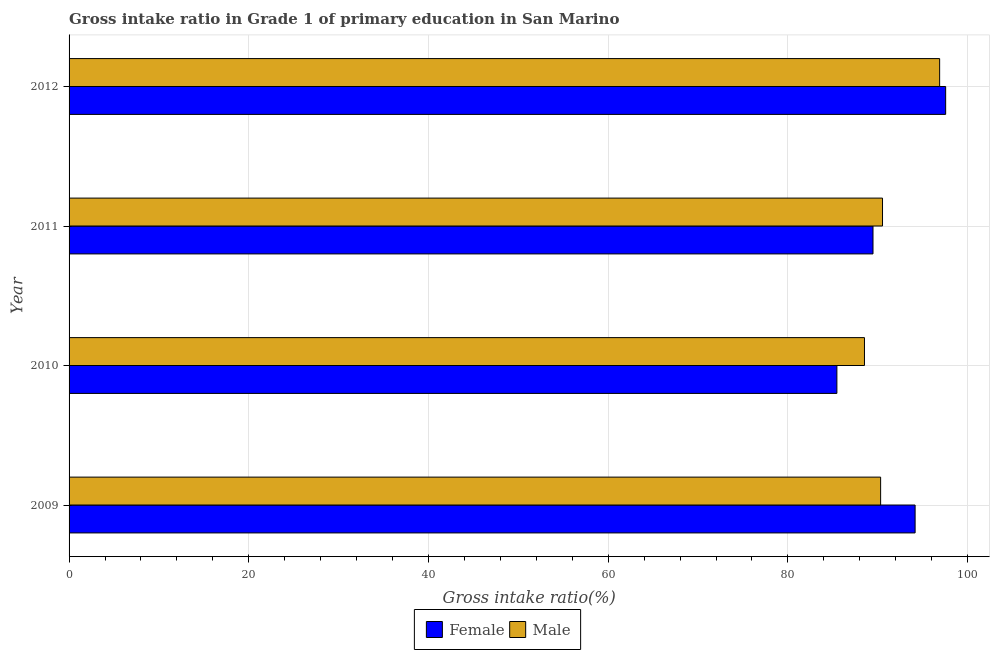How many different coloured bars are there?
Make the answer very short. 2. How many groups of bars are there?
Your response must be concise. 4. How many bars are there on the 3rd tick from the top?
Keep it short and to the point. 2. How many bars are there on the 1st tick from the bottom?
Your response must be concise. 2. In how many cases, is the number of bars for a given year not equal to the number of legend labels?
Offer a very short reply. 0. What is the gross intake ratio(female) in 2011?
Your answer should be very brief. 89.47. Across all years, what is the maximum gross intake ratio(male)?
Offer a terse response. 96.89. Across all years, what is the minimum gross intake ratio(female)?
Provide a succinct answer. 85.45. What is the total gross intake ratio(female) in the graph?
Keep it short and to the point. 366.65. What is the difference between the gross intake ratio(female) in 2009 and that in 2012?
Offer a very short reply. -3.4. What is the difference between the gross intake ratio(male) in 2009 and the gross intake ratio(female) in 2011?
Give a very brief answer. 0.85. What is the average gross intake ratio(male) per year?
Make the answer very short. 91.57. In the year 2010, what is the difference between the gross intake ratio(female) and gross intake ratio(male)?
Your answer should be very brief. -3.07. What is the ratio of the gross intake ratio(male) in 2010 to that in 2012?
Offer a terse response. 0.91. Is the gross intake ratio(female) in 2009 less than that in 2011?
Provide a short and direct response. No. What is the difference between the highest and the second highest gross intake ratio(male)?
Offer a very short reply. 6.36. What is the difference between the highest and the lowest gross intake ratio(male)?
Your answer should be very brief. 8.37. Is the sum of the gross intake ratio(female) in 2009 and 2012 greater than the maximum gross intake ratio(male) across all years?
Your answer should be compact. Yes. Are all the bars in the graph horizontal?
Provide a short and direct response. Yes. How many years are there in the graph?
Your answer should be compact. 4. What is the difference between two consecutive major ticks on the X-axis?
Keep it short and to the point. 20. How many legend labels are there?
Make the answer very short. 2. What is the title of the graph?
Make the answer very short. Gross intake ratio in Grade 1 of primary education in San Marino. What is the label or title of the X-axis?
Your answer should be compact. Gross intake ratio(%). What is the Gross intake ratio(%) in Female in 2009?
Offer a very short reply. 94.16. What is the Gross intake ratio(%) in Male in 2009?
Ensure brevity in your answer.  90.32. What is the Gross intake ratio(%) of Female in 2010?
Keep it short and to the point. 85.45. What is the Gross intake ratio(%) of Male in 2010?
Your answer should be very brief. 88.52. What is the Gross intake ratio(%) of Female in 2011?
Your answer should be very brief. 89.47. What is the Gross intake ratio(%) in Male in 2011?
Provide a succinct answer. 90.53. What is the Gross intake ratio(%) of Female in 2012?
Ensure brevity in your answer.  97.56. What is the Gross intake ratio(%) of Male in 2012?
Provide a short and direct response. 96.89. Across all years, what is the maximum Gross intake ratio(%) of Female?
Make the answer very short. 97.56. Across all years, what is the maximum Gross intake ratio(%) of Male?
Give a very brief answer. 96.89. Across all years, what is the minimum Gross intake ratio(%) of Female?
Give a very brief answer. 85.45. Across all years, what is the minimum Gross intake ratio(%) in Male?
Provide a succinct answer. 88.52. What is the total Gross intake ratio(%) of Female in the graph?
Your answer should be very brief. 366.65. What is the total Gross intake ratio(%) of Male in the graph?
Offer a terse response. 366.27. What is the difference between the Gross intake ratio(%) of Female in 2009 and that in 2010?
Ensure brevity in your answer.  8.71. What is the difference between the Gross intake ratio(%) in Male in 2009 and that in 2010?
Your answer should be very brief. 1.8. What is the difference between the Gross intake ratio(%) in Female in 2009 and that in 2011?
Offer a very short reply. 4.69. What is the difference between the Gross intake ratio(%) of Male in 2009 and that in 2011?
Ensure brevity in your answer.  -0.21. What is the difference between the Gross intake ratio(%) of Female in 2009 and that in 2012?
Offer a very short reply. -3.4. What is the difference between the Gross intake ratio(%) in Male in 2009 and that in 2012?
Offer a very short reply. -6.57. What is the difference between the Gross intake ratio(%) of Female in 2010 and that in 2011?
Make the answer very short. -4.02. What is the difference between the Gross intake ratio(%) of Male in 2010 and that in 2011?
Keep it short and to the point. -2.01. What is the difference between the Gross intake ratio(%) in Female in 2010 and that in 2012?
Offer a very short reply. -12.11. What is the difference between the Gross intake ratio(%) in Male in 2010 and that in 2012?
Offer a very short reply. -8.37. What is the difference between the Gross intake ratio(%) of Female in 2011 and that in 2012?
Provide a succinct answer. -8.09. What is the difference between the Gross intake ratio(%) in Male in 2011 and that in 2012?
Make the answer very short. -6.36. What is the difference between the Gross intake ratio(%) in Female in 2009 and the Gross intake ratio(%) in Male in 2010?
Ensure brevity in your answer.  5.64. What is the difference between the Gross intake ratio(%) in Female in 2009 and the Gross intake ratio(%) in Male in 2011?
Your response must be concise. 3.63. What is the difference between the Gross intake ratio(%) in Female in 2009 and the Gross intake ratio(%) in Male in 2012?
Offer a very short reply. -2.73. What is the difference between the Gross intake ratio(%) in Female in 2010 and the Gross intake ratio(%) in Male in 2011?
Offer a very short reply. -5.08. What is the difference between the Gross intake ratio(%) of Female in 2010 and the Gross intake ratio(%) of Male in 2012?
Your response must be concise. -11.44. What is the difference between the Gross intake ratio(%) in Female in 2011 and the Gross intake ratio(%) in Male in 2012?
Make the answer very short. -7.42. What is the average Gross intake ratio(%) of Female per year?
Provide a succinct answer. 91.66. What is the average Gross intake ratio(%) of Male per year?
Ensure brevity in your answer.  91.57. In the year 2009, what is the difference between the Gross intake ratio(%) in Female and Gross intake ratio(%) in Male?
Your answer should be compact. 3.84. In the year 2010, what is the difference between the Gross intake ratio(%) of Female and Gross intake ratio(%) of Male?
Offer a very short reply. -3.07. In the year 2011, what is the difference between the Gross intake ratio(%) in Female and Gross intake ratio(%) in Male?
Provide a succinct answer. -1.06. In the year 2012, what is the difference between the Gross intake ratio(%) of Female and Gross intake ratio(%) of Male?
Give a very brief answer. 0.67. What is the ratio of the Gross intake ratio(%) of Female in 2009 to that in 2010?
Your response must be concise. 1.1. What is the ratio of the Gross intake ratio(%) of Male in 2009 to that in 2010?
Give a very brief answer. 1.02. What is the ratio of the Gross intake ratio(%) of Female in 2009 to that in 2011?
Give a very brief answer. 1.05. What is the ratio of the Gross intake ratio(%) of Male in 2009 to that in 2011?
Your response must be concise. 1. What is the ratio of the Gross intake ratio(%) of Female in 2009 to that in 2012?
Ensure brevity in your answer.  0.97. What is the ratio of the Gross intake ratio(%) of Male in 2009 to that in 2012?
Provide a succinct answer. 0.93. What is the ratio of the Gross intake ratio(%) of Female in 2010 to that in 2011?
Your response must be concise. 0.96. What is the ratio of the Gross intake ratio(%) of Male in 2010 to that in 2011?
Your answer should be very brief. 0.98. What is the ratio of the Gross intake ratio(%) in Female in 2010 to that in 2012?
Provide a succinct answer. 0.88. What is the ratio of the Gross intake ratio(%) of Male in 2010 to that in 2012?
Your response must be concise. 0.91. What is the ratio of the Gross intake ratio(%) in Female in 2011 to that in 2012?
Offer a terse response. 0.92. What is the ratio of the Gross intake ratio(%) in Male in 2011 to that in 2012?
Keep it short and to the point. 0.93. What is the difference between the highest and the second highest Gross intake ratio(%) in Female?
Provide a succinct answer. 3.4. What is the difference between the highest and the second highest Gross intake ratio(%) of Male?
Keep it short and to the point. 6.36. What is the difference between the highest and the lowest Gross intake ratio(%) of Female?
Provide a succinct answer. 12.11. What is the difference between the highest and the lowest Gross intake ratio(%) of Male?
Make the answer very short. 8.37. 